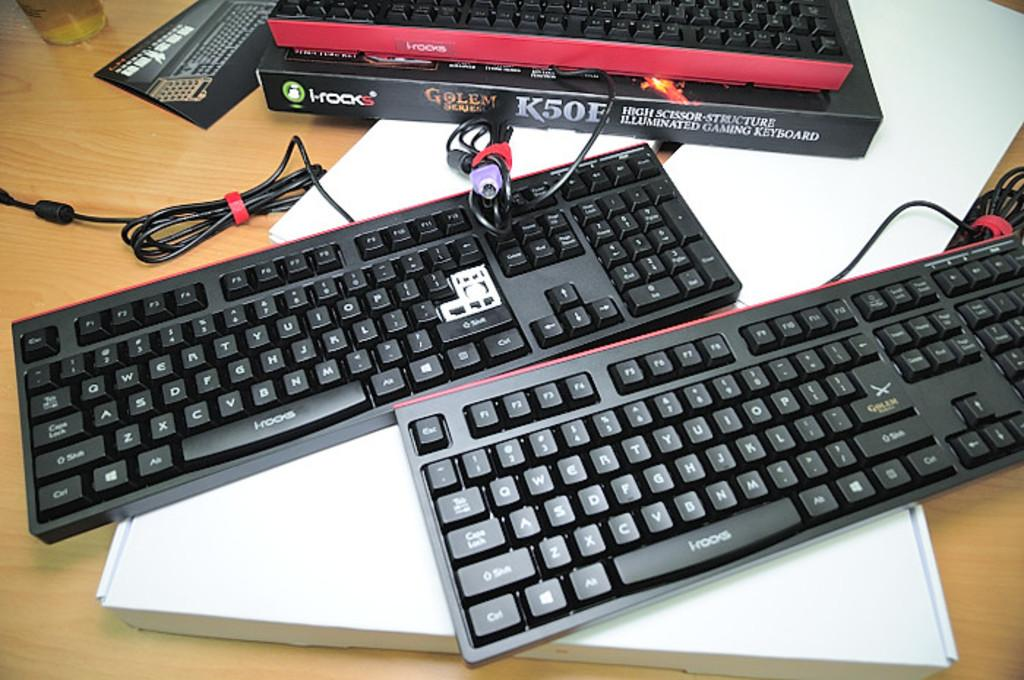<image>
Write a terse but informative summary of the picture. A keyboard has the Golem logo on the enter key. 